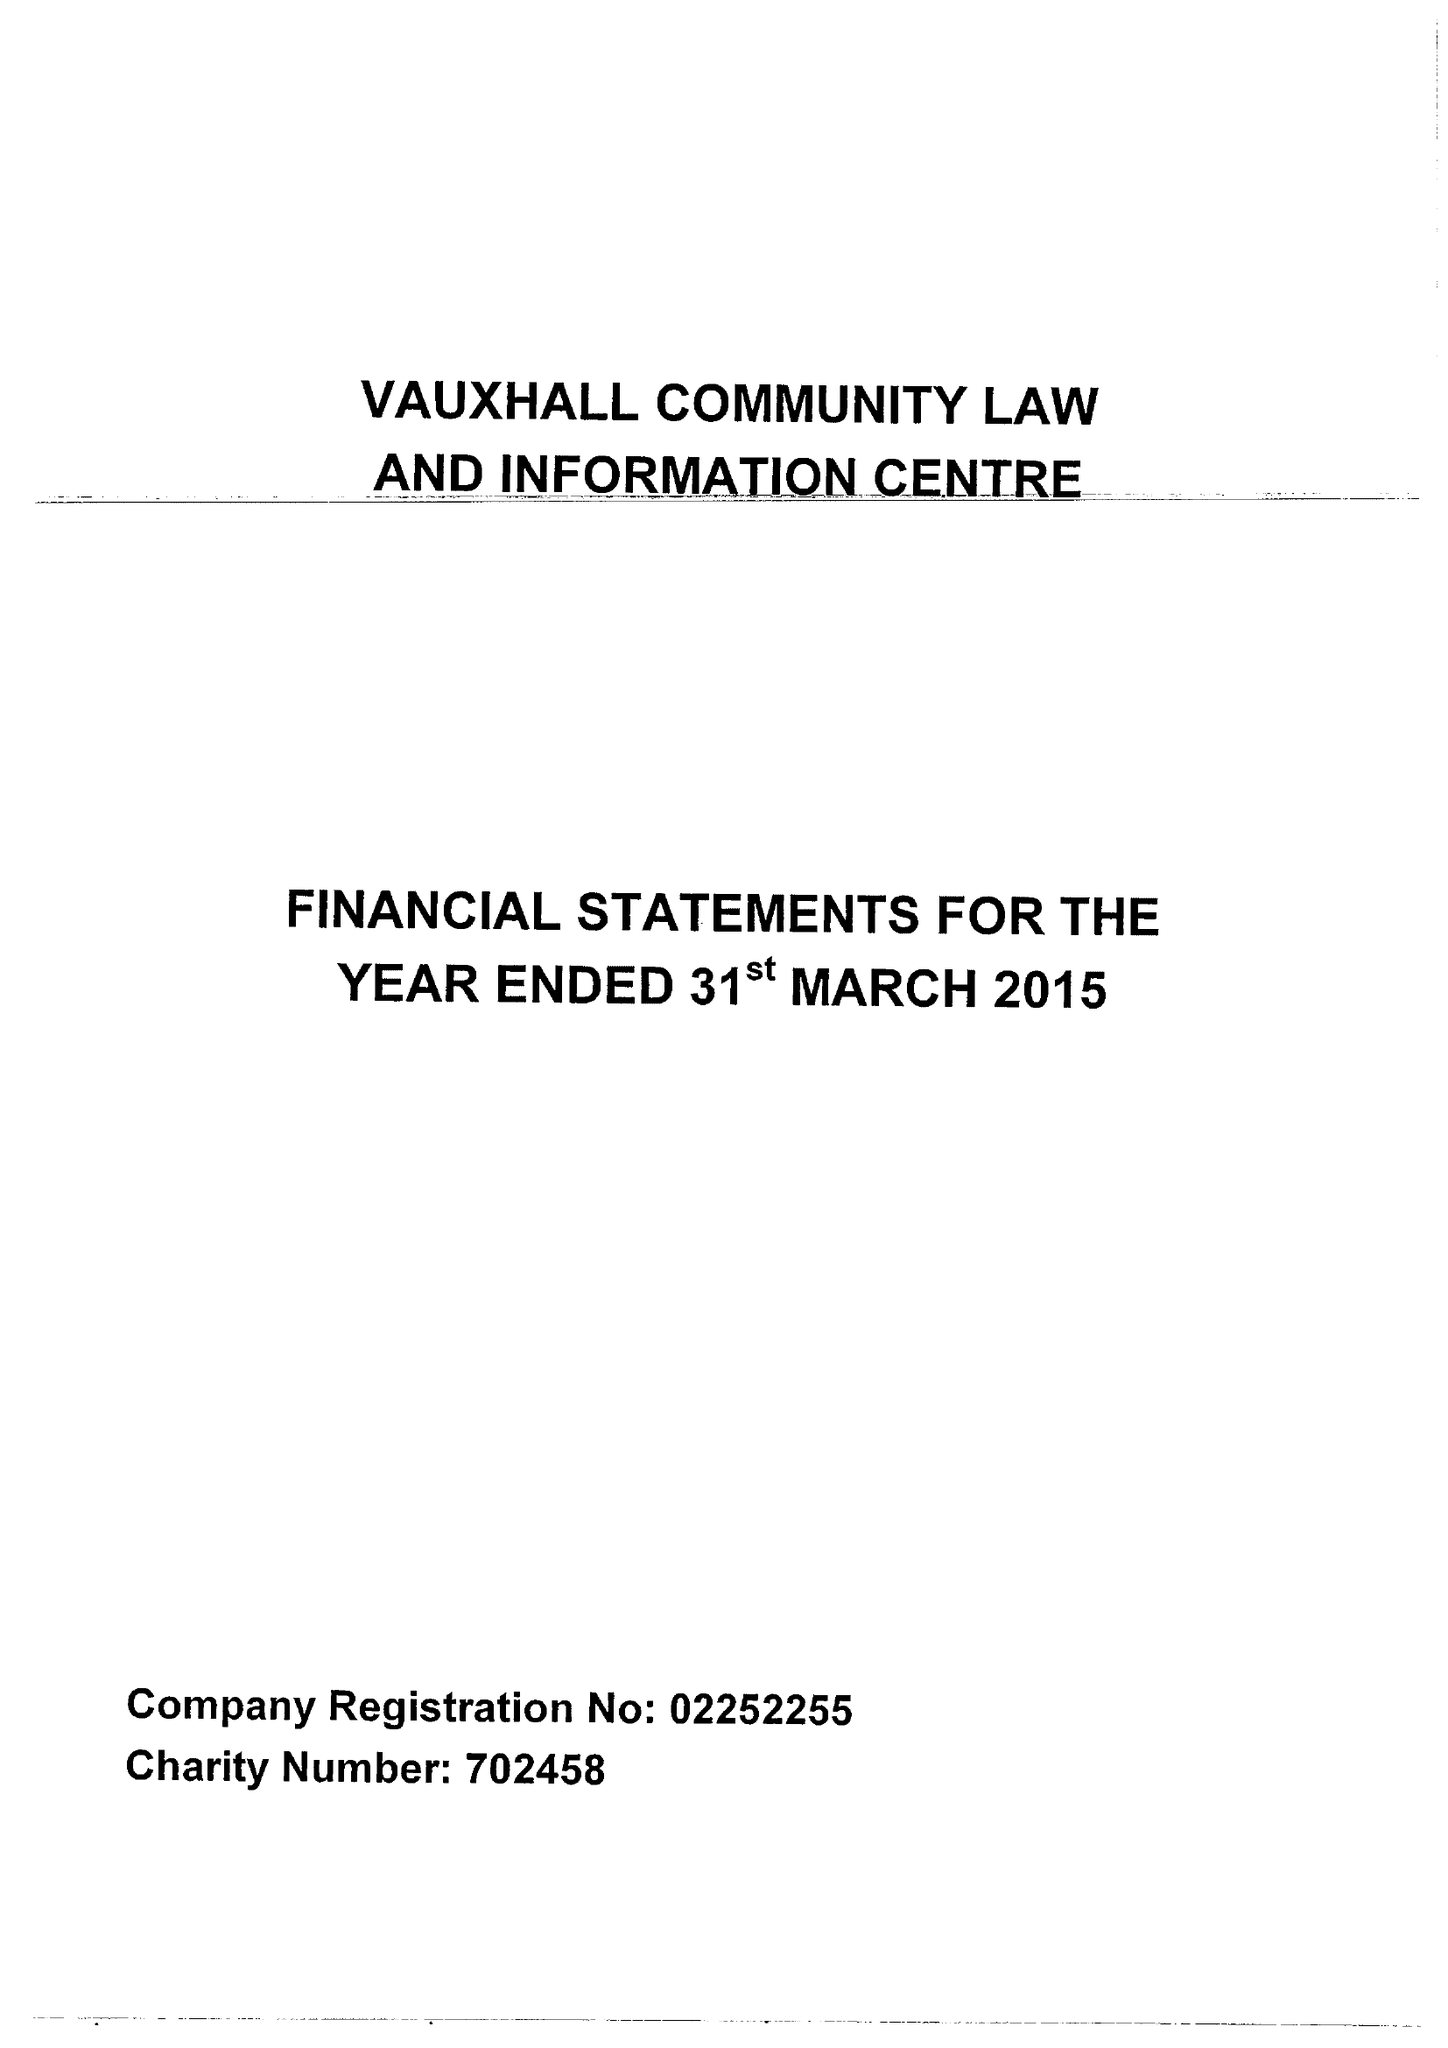What is the value for the income_annually_in_british_pounds?
Answer the question using a single word or phrase. 67289.00 